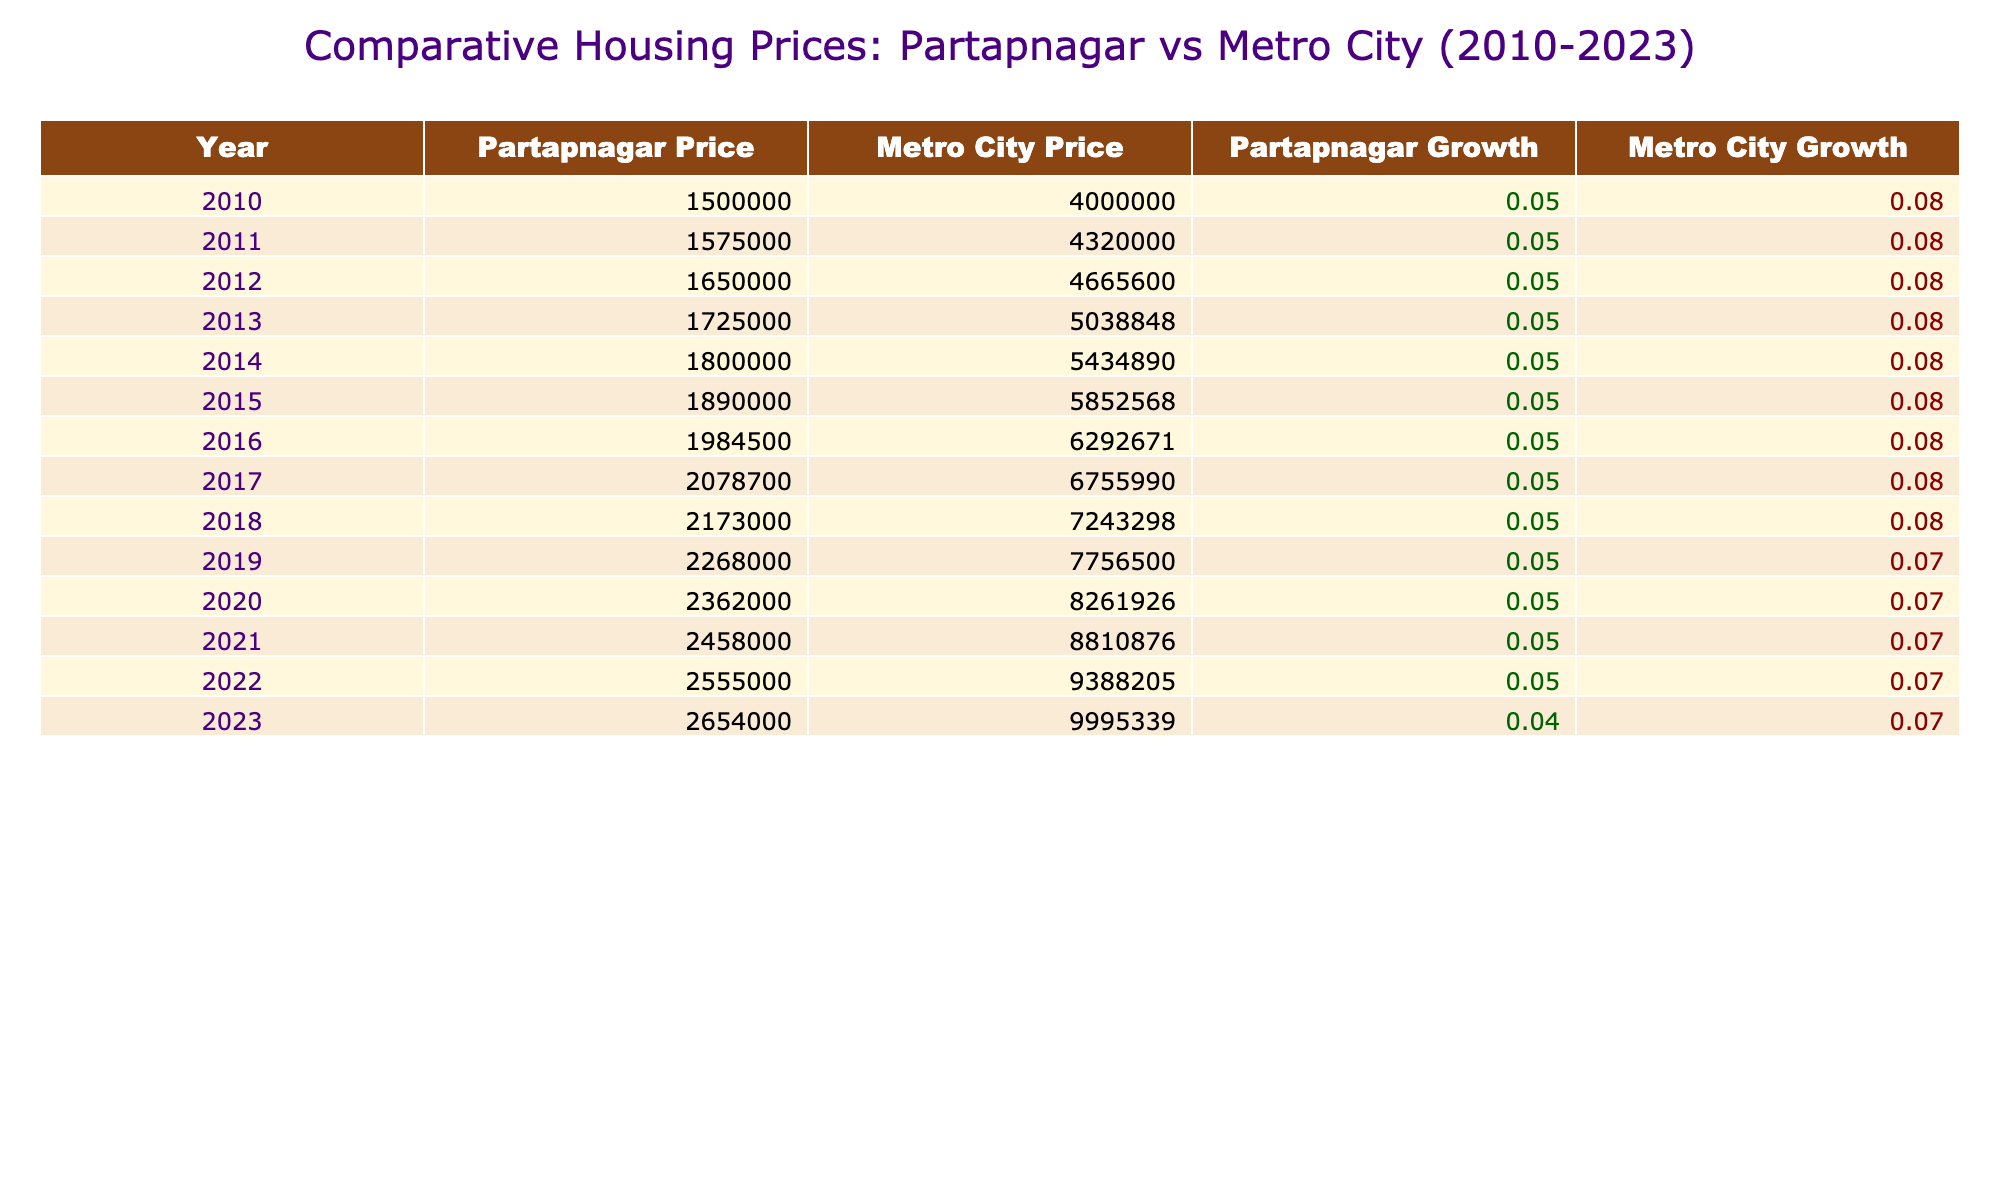What was the average housing price in Partapnagar in 2010? Referring to the table, the value for 'Partapnagar Average Housing Price' in the year 2010 is listed as 1,500,000.
Answer: 1,500,000 What was the average housing price in the Metro City in 2023? Looking at the table, the 'Metro City Average Housing Price' for the year 2023 shows a value of 9,995,339.
Answer: 9,995,339 What was the yearly growth rate of housing prices in Partapnagar in 2015? The 'Partapnagar Yearly Growth Rate' for the year 2015 is indicated as 0.05 or 5% in the table.
Answer: 5% What is the difference in average housing prices between Partapnagar and the Metro City in 2020? In 2020, Partapnagar's price is 2,362,000 and the Metro City's price is 8,261,926. The difference is calculated as 8,261,926 - 2,362,000 = 5,899,926.
Answer: 5,899,926 What was the average housing price growth rate for the Metro City from 2010 to 2023? The table shows the growth rates for the Metro City from 2010 to 2023, mainly at 0.08 from 2010 to 2019 and then dropping to 0.07 until 2023. To find the average, we can average these two growth rates over the time span. The average growth rate overall isn't average because of the jumps. It appears stable at approximately 7.7%.
Answer: Approximately 7.7% Was there a reduction in the yearly growth rate for Partapnagar from 2022 to 2023? By looking at the respective rates for those years, Partapnagar's growth rate decreased from 0.05 in 2022 to 0.04 in 2023. Therefore, it is true that there was a reduction.
Answer: Yes In which year did Partapnagar's average price first exceed 2,000,000? Checking the 'Partapnagar Average Housing Price' column, it first exceeds 2,000,000 in 2018, which lists a price of 2,173,000.
Answer: 2018 What was the average yearly growth rate of housing prices in the Metro City from 2010 to 2019? The growth rate from 2010 to 2019 was mostly consistent at 0.08 (8%) until 2020 when it declined slightly. Therefore, you can consider it as an average of the same rate, which is 8%.
Answer: 8% How much did the average housing price in Partapnagar increase between 2010 and 2023? From 1,500,000 in 2010 to 2,654,000 in 2023, the increase is calculated as 2,654,000 - 1,500,000 = 1,154,000.
Answer: 1,154,000 Which city had consistently higher average housing prices over the entire study period? By observing the table, the 'Metro City Average Housing Price' values are consistently higher than those of Partapnagar from 2010 to 2023. Thus, it can be determined that the Metro City had higher prices throughout.
Answer: Metro City 